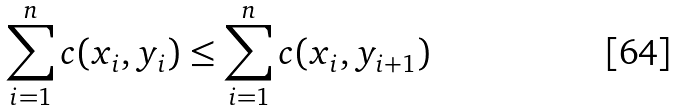<formula> <loc_0><loc_0><loc_500><loc_500>\sum _ { i = 1 } ^ { n } c ( x _ { i } , y _ { i } ) \leq \sum _ { i = 1 } ^ { n } c ( x _ { i } , y _ { i + 1 } )</formula> 